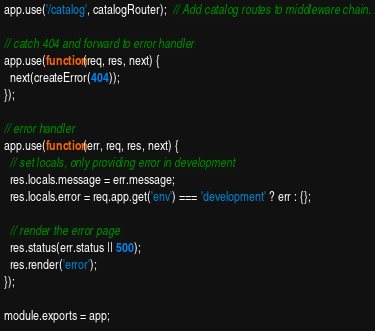Convert code to text. <code><loc_0><loc_0><loc_500><loc_500><_JavaScript_>app.use('/catalog', catalogRouter);  // Add catalog routes to middleware chain.

// catch 404 and forward to error handler
app.use(function(req, res, next) {
  next(createError(404));
});

// error handler
app.use(function(err, req, res, next) {
  // set locals, only providing error in development
  res.locals.message = err.message;
  res.locals.error = req.app.get('env') === 'development' ? err : {};

  // render the error page
  res.status(err.status || 500);
  res.render('error');
});

module.exports = app;
</code> 